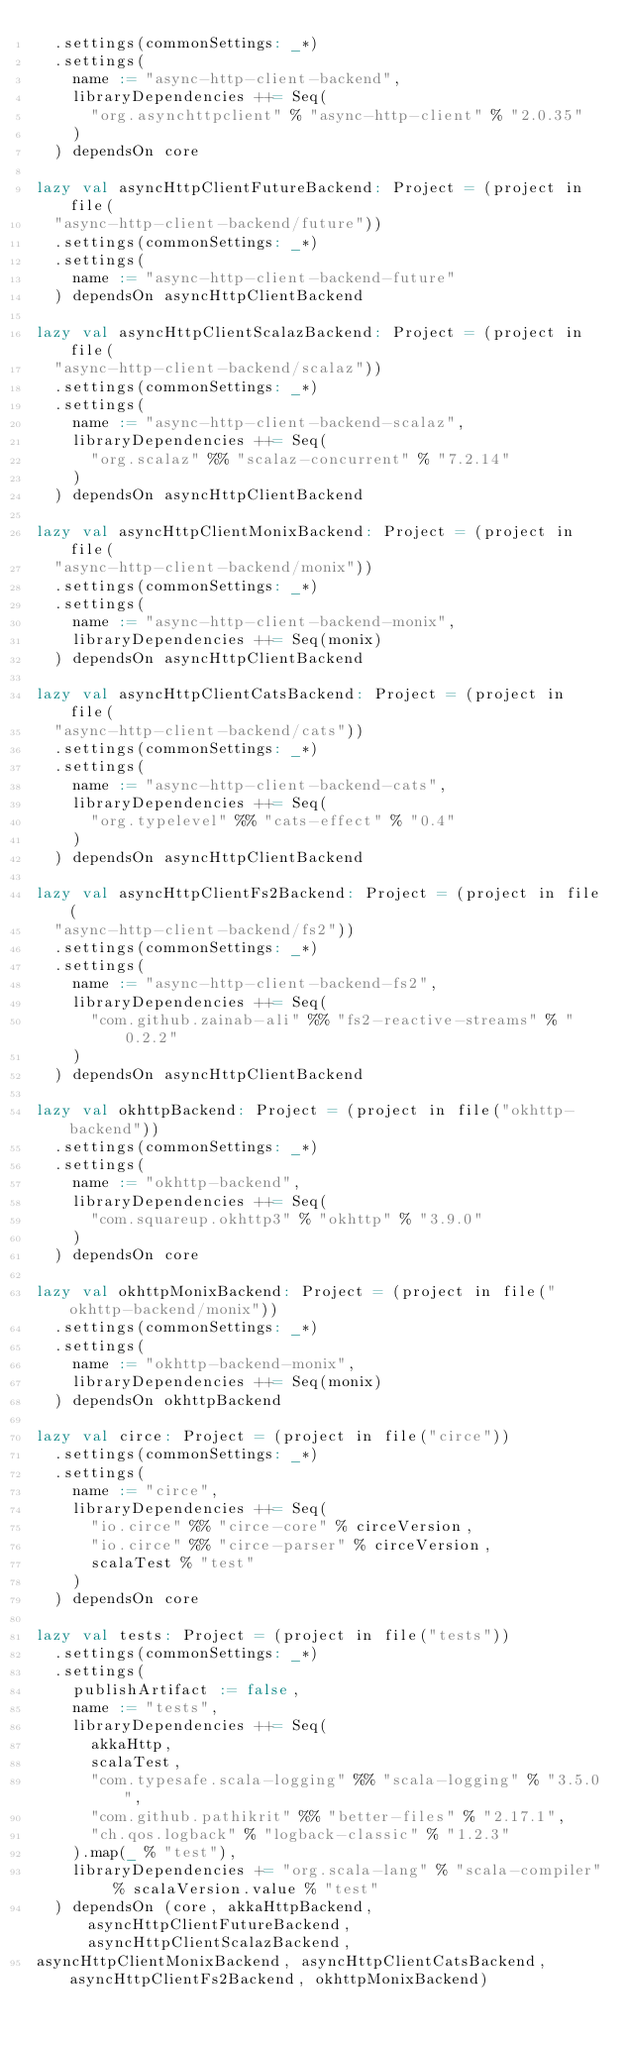Convert code to text. <code><loc_0><loc_0><loc_500><loc_500><_Scala_>  .settings(commonSettings: _*)
  .settings(
    name := "async-http-client-backend",
    libraryDependencies ++= Seq(
      "org.asynchttpclient" % "async-http-client" % "2.0.35"
    )
  ) dependsOn core

lazy val asyncHttpClientFutureBackend: Project = (project in file(
  "async-http-client-backend/future"))
  .settings(commonSettings: _*)
  .settings(
    name := "async-http-client-backend-future"
  ) dependsOn asyncHttpClientBackend

lazy val asyncHttpClientScalazBackend: Project = (project in file(
  "async-http-client-backend/scalaz"))
  .settings(commonSettings: _*)
  .settings(
    name := "async-http-client-backend-scalaz",
    libraryDependencies ++= Seq(
      "org.scalaz" %% "scalaz-concurrent" % "7.2.14"
    )
  ) dependsOn asyncHttpClientBackend

lazy val asyncHttpClientMonixBackend: Project = (project in file(
  "async-http-client-backend/monix"))
  .settings(commonSettings: _*)
  .settings(
    name := "async-http-client-backend-monix",
    libraryDependencies ++= Seq(monix)
  ) dependsOn asyncHttpClientBackend

lazy val asyncHttpClientCatsBackend: Project = (project in file(
  "async-http-client-backend/cats"))
  .settings(commonSettings: _*)
  .settings(
    name := "async-http-client-backend-cats",
    libraryDependencies ++= Seq(
      "org.typelevel" %% "cats-effect" % "0.4"
    )
  ) dependsOn asyncHttpClientBackend

lazy val asyncHttpClientFs2Backend: Project = (project in file(
  "async-http-client-backend/fs2"))
  .settings(commonSettings: _*)
  .settings(
    name := "async-http-client-backend-fs2",
    libraryDependencies ++= Seq(
      "com.github.zainab-ali" %% "fs2-reactive-streams" % "0.2.2"
    )
  ) dependsOn asyncHttpClientBackend

lazy val okhttpBackend: Project = (project in file("okhttp-backend"))
  .settings(commonSettings: _*)
  .settings(
    name := "okhttp-backend",
    libraryDependencies ++= Seq(
      "com.squareup.okhttp3" % "okhttp" % "3.9.0"
    )
  ) dependsOn core

lazy val okhttpMonixBackend: Project = (project in file("okhttp-backend/monix"))
  .settings(commonSettings: _*)
  .settings(
    name := "okhttp-backend-monix",
    libraryDependencies ++= Seq(monix)
  ) dependsOn okhttpBackend

lazy val circe: Project = (project in file("circe"))
  .settings(commonSettings: _*)
  .settings(
    name := "circe",
    libraryDependencies ++= Seq(
      "io.circe" %% "circe-core" % circeVersion,
      "io.circe" %% "circe-parser" % circeVersion,
      scalaTest % "test"
    )
  ) dependsOn core

lazy val tests: Project = (project in file("tests"))
  .settings(commonSettings: _*)
  .settings(
    publishArtifact := false,
    name := "tests",
    libraryDependencies ++= Seq(
      akkaHttp,
      scalaTest,
      "com.typesafe.scala-logging" %% "scala-logging" % "3.5.0",
      "com.github.pathikrit" %% "better-files" % "2.17.1",
      "ch.qos.logback" % "logback-classic" % "1.2.3"
    ).map(_ % "test"),
    libraryDependencies += "org.scala-lang" % "scala-compiler" % scalaVersion.value % "test"
  ) dependsOn (core, akkaHttpBackend, asyncHttpClientFutureBackend, asyncHttpClientScalazBackend,
asyncHttpClientMonixBackend, asyncHttpClientCatsBackend, asyncHttpClientFs2Backend, okhttpMonixBackend)
</code> 